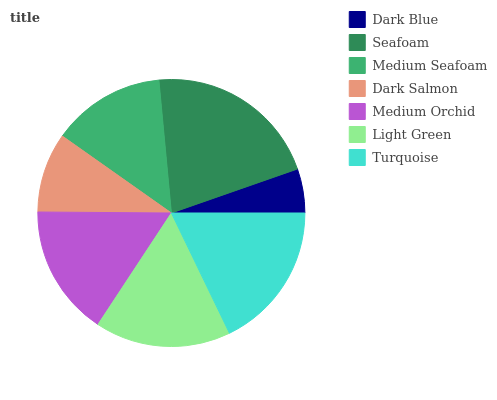Is Dark Blue the minimum?
Answer yes or no. Yes. Is Seafoam the maximum?
Answer yes or no. Yes. Is Medium Seafoam the minimum?
Answer yes or no. No. Is Medium Seafoam the maximum?
Answer yes or no. No. Is Seafoam greater than Medium Seafoam?
Answer yes or no. Yes. Is Medium Seafoam less than Seafoam?
Answer yes or no. Yes. Is Medium Seafoam greater than Seafoam?
Answer yes or no. No. Is Seafoam less than Medium Seafoam?
Answer yes or no. No. Is Medium Orchid the high median?
Answer yes or no. Yes. Is Medium Orchid the low median?
Answer yes or no. Yes. Is Turquoise the high median?
Answer yes or no. No. Is Medium Seafoam the low median?
Answer yes or no. No. 